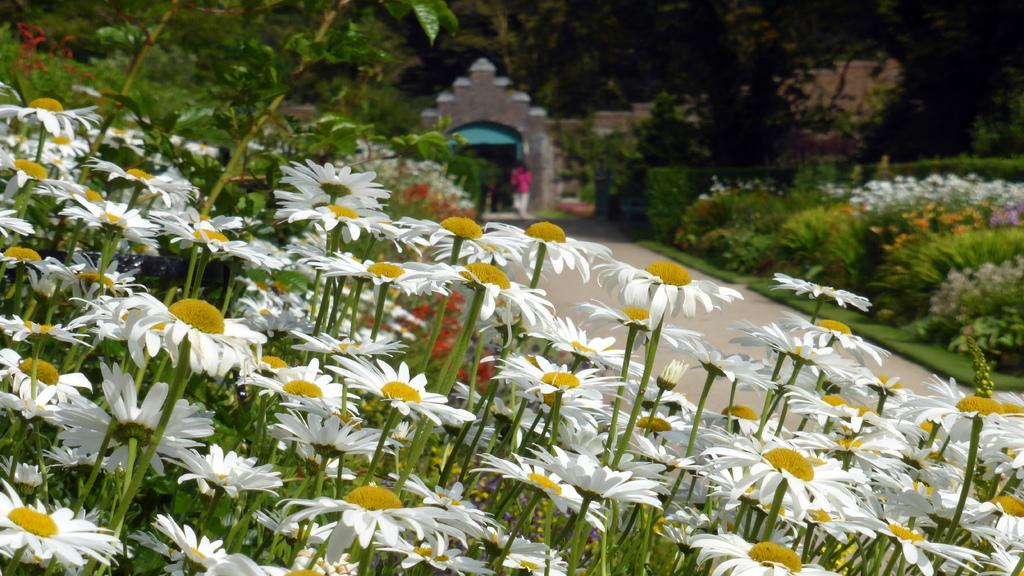What type of vegetation can be seen in the image? There are flowers, plants, and trees in the image. Can you describe the person in the image? There is a person in the image, but no specific details about their appearance or actions are provided. What architectural feature is present in the image? There is an arch in the image. What type of animals can be seen in the zoo in the image? There is no zoo present in the image, and therefore no animals can be observed. What advice does the mother give to the person in the image? There is no mention of a mother or any advice-giving in the image. 